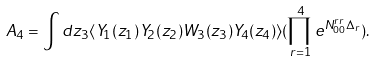<formula> <loc_0><loc_0><loc_500><loc_500>A _ { 4 } = \int d z _ { 3 } \langle Y _ { 1 } ( z _ { 1 } ) Y _ { 2 } ( z _ { 2 } ) W _ { 3 } ( z _ { 3 } ) Y _ { 4 } ( z _ { 4 } ) \rangle ( \prod _ { r = 1 } ^ { 4 } e ^ { N ^ { r r } _ { 0 0 } \Delta _ { r } } ) .</formula> 